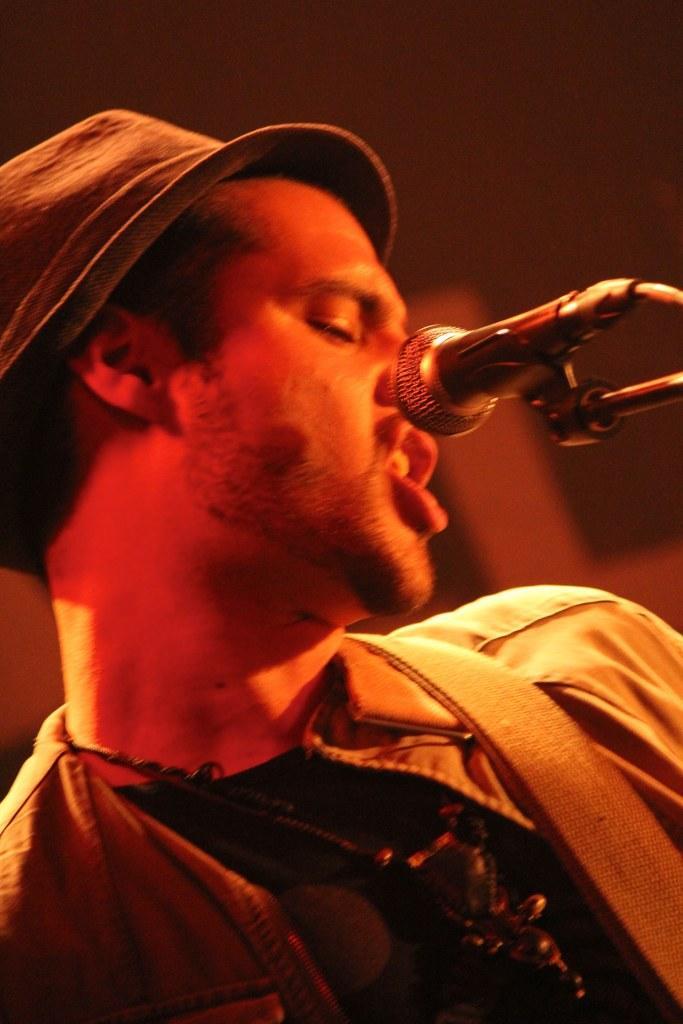Can you describe this image briefly? In this image I see a man who is wearing a hat and I see a mic over here and I see that it is blurred in the background. 